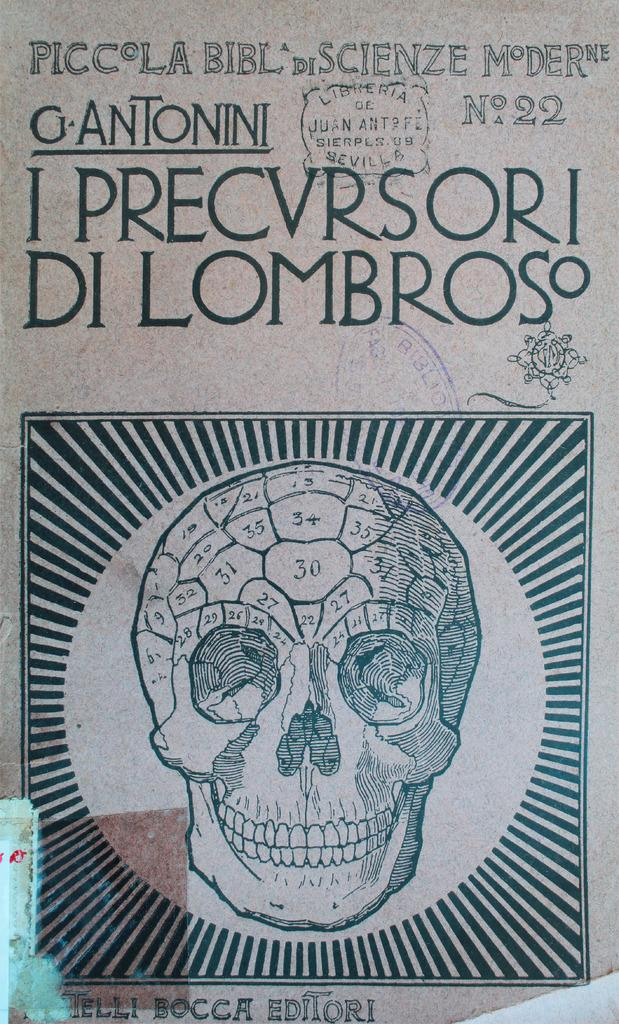Provide a one-sentence caption for the provided image. Piccola Bibl di scienze moderne gantonni I precvrsori Di Lombroso. 